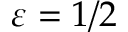<formula> <loc_0><loc_0><loc_500><loc_500>\varepsilon = 1 / 2</formula> 